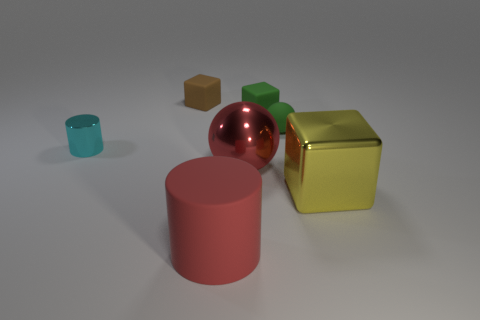How many other objects are the same color as the large shiny block?
Give a very brief answer. 0. There is a block that is in front of the cyan cylinder; is it the same size as the tiny cyan metallic thing?
Offer a terse response. No. Are there any red spheres of the same size as the green cube?
Your response must be concise. No. What is the color of the matte object that is in front of the cyan metallic cylinder?
Provide a short and direct response. Red. What is the shape of the metallic object that is to the right of the red cylinder and behind the big yellow object?
Your answer should be compact. Sphere. How many other brown rubber things have the same shape as the tiny brown rubber thing?
Your answer should be very brief. 0. What number of big gray blocks are there?
Make the answer very short. 0. There is a thing that is on the left side of the large red cylinder and to the right of the cyan metallic cylinder; what is its size?
Provide a short and direct response. Small. There is a red shiny object that is the same size as the red rubber object; what shape is it?
Provide a short and direct response. Sphere. Is there a large cylinder behind the ball that is behind the shiny ball?
Offer a terse response. No. 